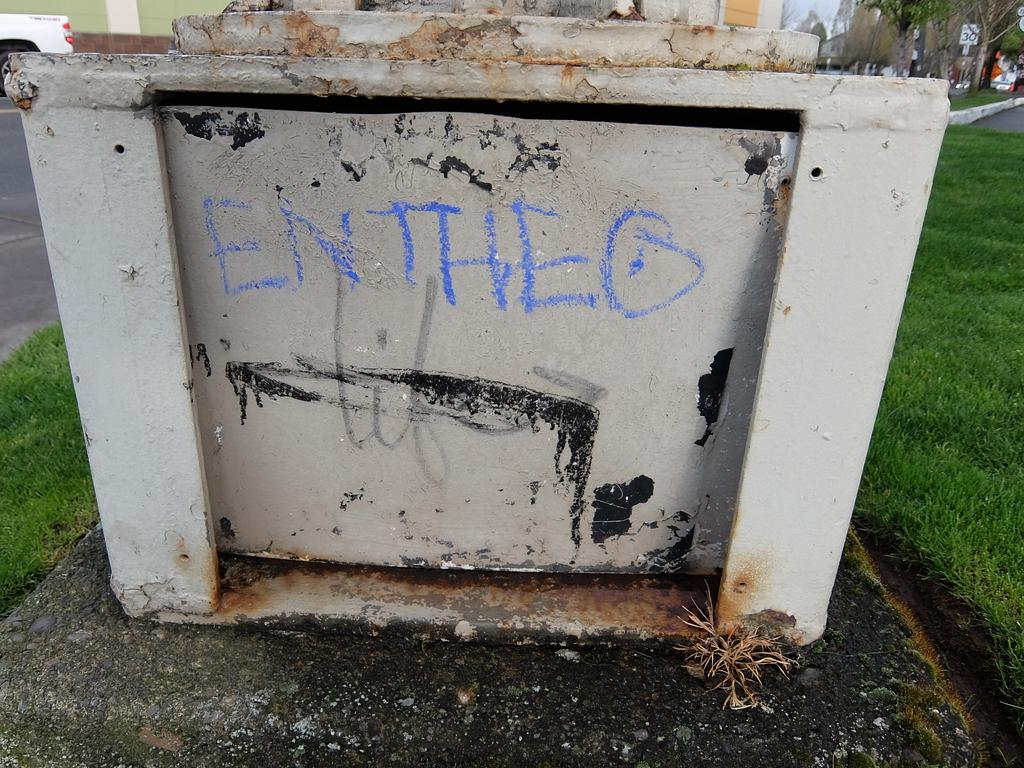What is there is a structure made of iron in the image, what is it? There is an iron frame in the image. What is written on the iron frame? Text is written on the iron frame using a chalk piece. What is the ground covered with in the image? The ground is covered with grass in the image. What game is being played on the iron frame in the image? There is no game being played on the iron frame in the image; it is just an iron frame with text written on it. 